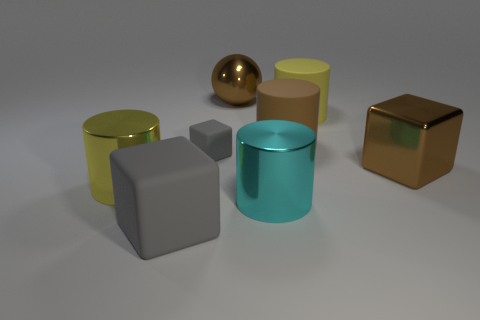What material is the big cyan thing that is the same shape as the large yellow matte thing?
Give a very brief answer. Metal. There is a matte block that is behind the large cylinder that is on the left side of the large gray block; what is its size?
Offer a terse response. Small. Are there any small red cylinders?
Keep it short and to the point. No. The big object that is right of the ball and to the left of the big brown rubber cylinder is made of what material?
Provide a short and direct response. Metal. Are there more big yellow objects that are in front of the big brown cube than blocks that are behind the tiny thing?
Your answer should be compact. Yes. Are there any brown cubes that have the same size as the yellow rubber object?
Your answer should be compact. Yes. There is a gray matte cube that is behind the big cyan metal thing in front of the gray rubber cube behind the large matte cube; what is its size?
Make the answer very short. Small. The metallic sphere is what color?
Make the answer very short. Brown. Are there more metallic objects that are to the left of the big cyan thing than small red rubber cubes?
Your answer should be very brief. Yes. There is a big metal ball; what number of large brown things are in front of it?
Your response must be concise. 2. 